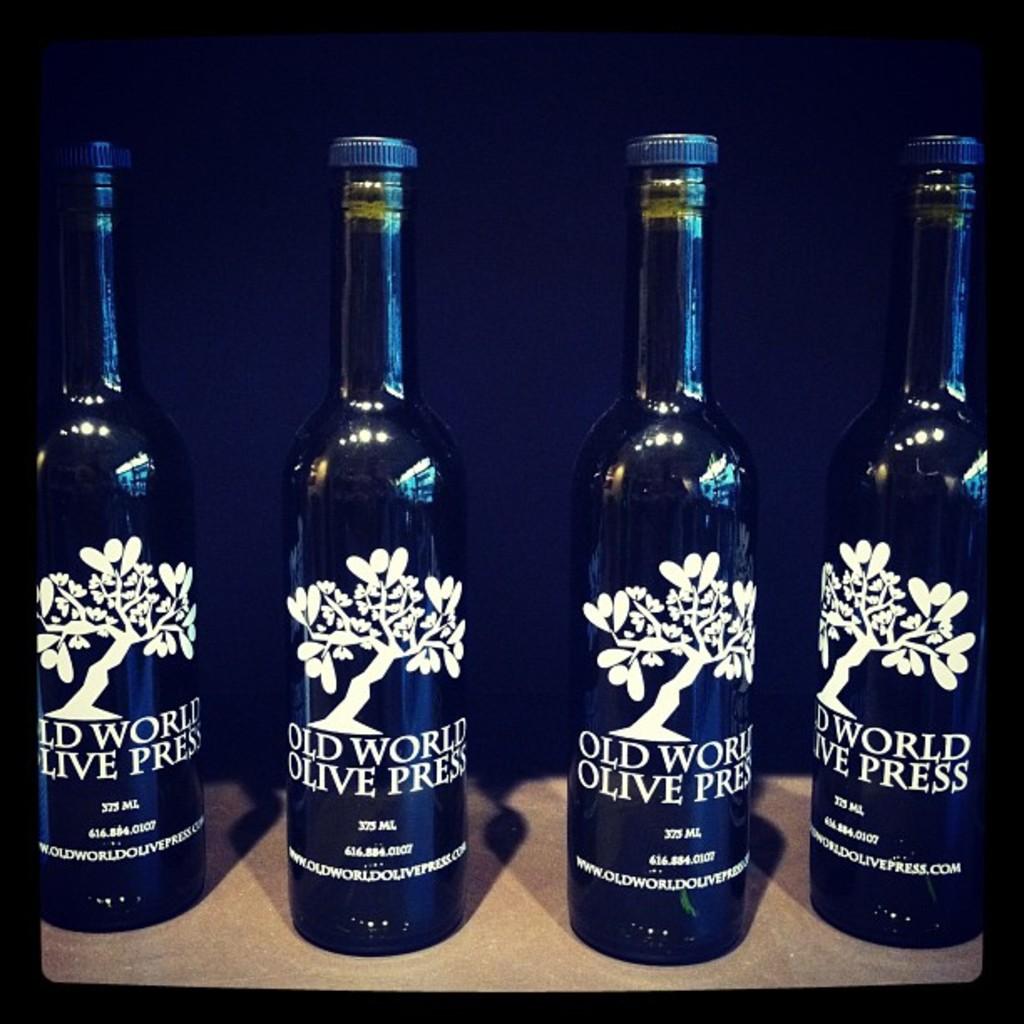What kind of wine is this?
Ensure brevity in your answer.  Old world olive press. How much can this container hold?
Give a very brief answer. 375 ml. 